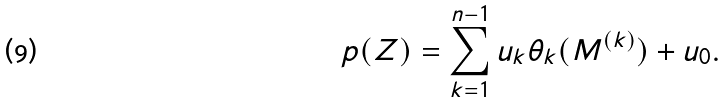Convert formula to latex. <formula><loc_0><loc_0><loc_500><loc_500>p ( Z ) = \sum _ { k = 1 } ^ { n - 1 } u _ { k } \theta _ { k } ( M ^ { ( k ) } ) + u _ { 0 } .</formula> 